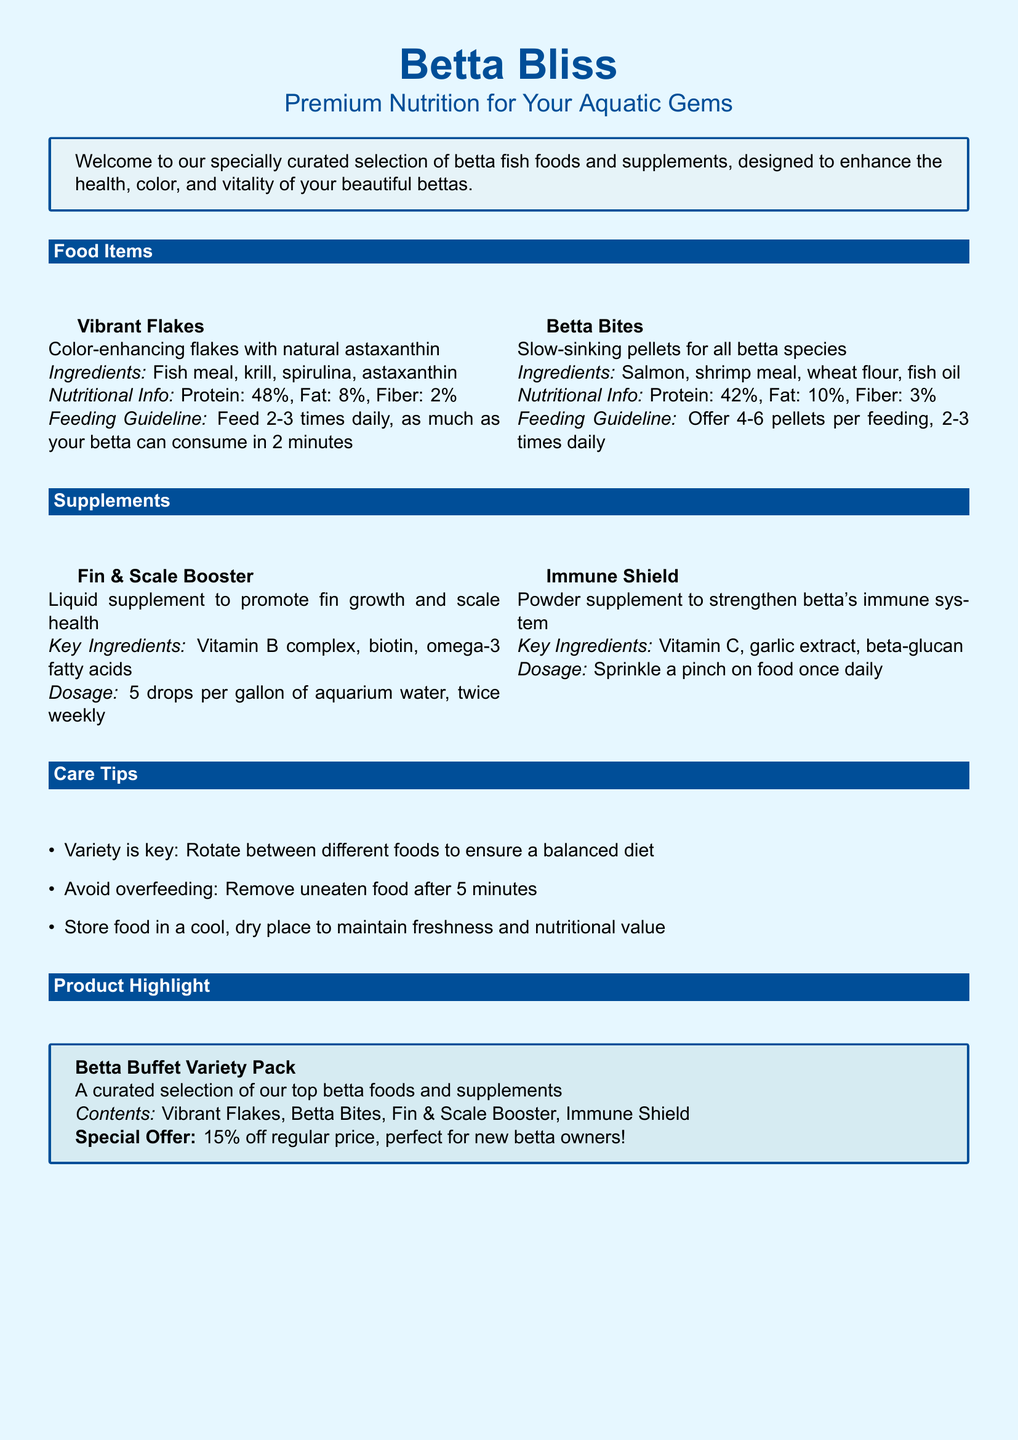what is the protein percentage in Vibrant Flakes? The protein percentage in Vibrant Flakes is listed in the nutritional information section of the document.
Answer: 48% what are the key ingredients in Immune Shield? The key ingredients for Immune Shield are provided in the supplements section.
Answer: Vitamin C, garlic extract, beta-glucan how many drops of Fin & Scale Booster should be added per gallon? The dosage for Fin & Scale Booster is stated in the supplement section of the document.
Answer: 5 drops what is the special offer on the Betta Buffet Variety Pack? The special offer for the Betta Buffet Variety Pack is highlighted in the product highlight section.
Answer: 15% off how many pellets should be offered per feeding for Betta Bites? The feeding guideline for Betta Bites specifies a number of pellets to offer at each feeding.
Answer: 4-6 pellets what is the fat percentage in Betta Bites? The fat percentage for Betta Bites is part of the nutritional information included in the document.
Answer: 10% what is the recommended storage condition for fish food? The care tips section suggests best practices for storing fish food.
Answer: Cool, dry place what type of product is Betta Buffet Variety Pack? The Betta Buffet Variety Pack category is clearly defined in the product highlight section of the document.
Answer: A curated selection of betta foods and supplements 